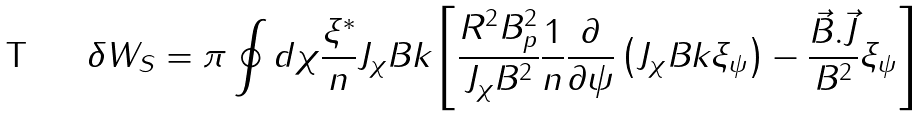<formula> <loc_0><loc_0><loc_500><loc_500>\delta W _ { S } = \pi \oint d \chi \frac { \xi ^ { * } } { n } J _ { \chi } B k _ { \| } \left [ \frac { R ^ { 2 } B _ { p } ^ { 2 } } { J _ { \chi } B ^ { 2 } } \frac { 1 } { n } \frac { \partial } { \partial \psi } \left ( J _ { \chi } B k _ { \| } \xi _ { \psi } \right ) - \frac { \vec { B } . \vec { J } } { B ^ { 2 } } \xi _ { \psi } \right ]</formula> 